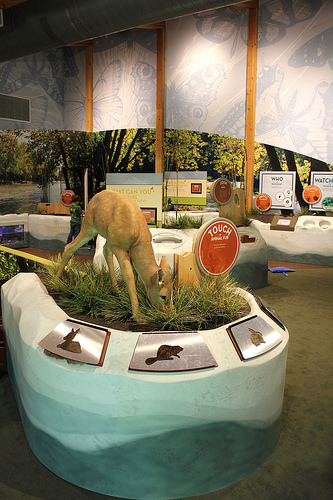<image>
Is there a deer on the display? Yes. Looking at the image, I can see the deer is positioned on top of the display, with the display providing support. 